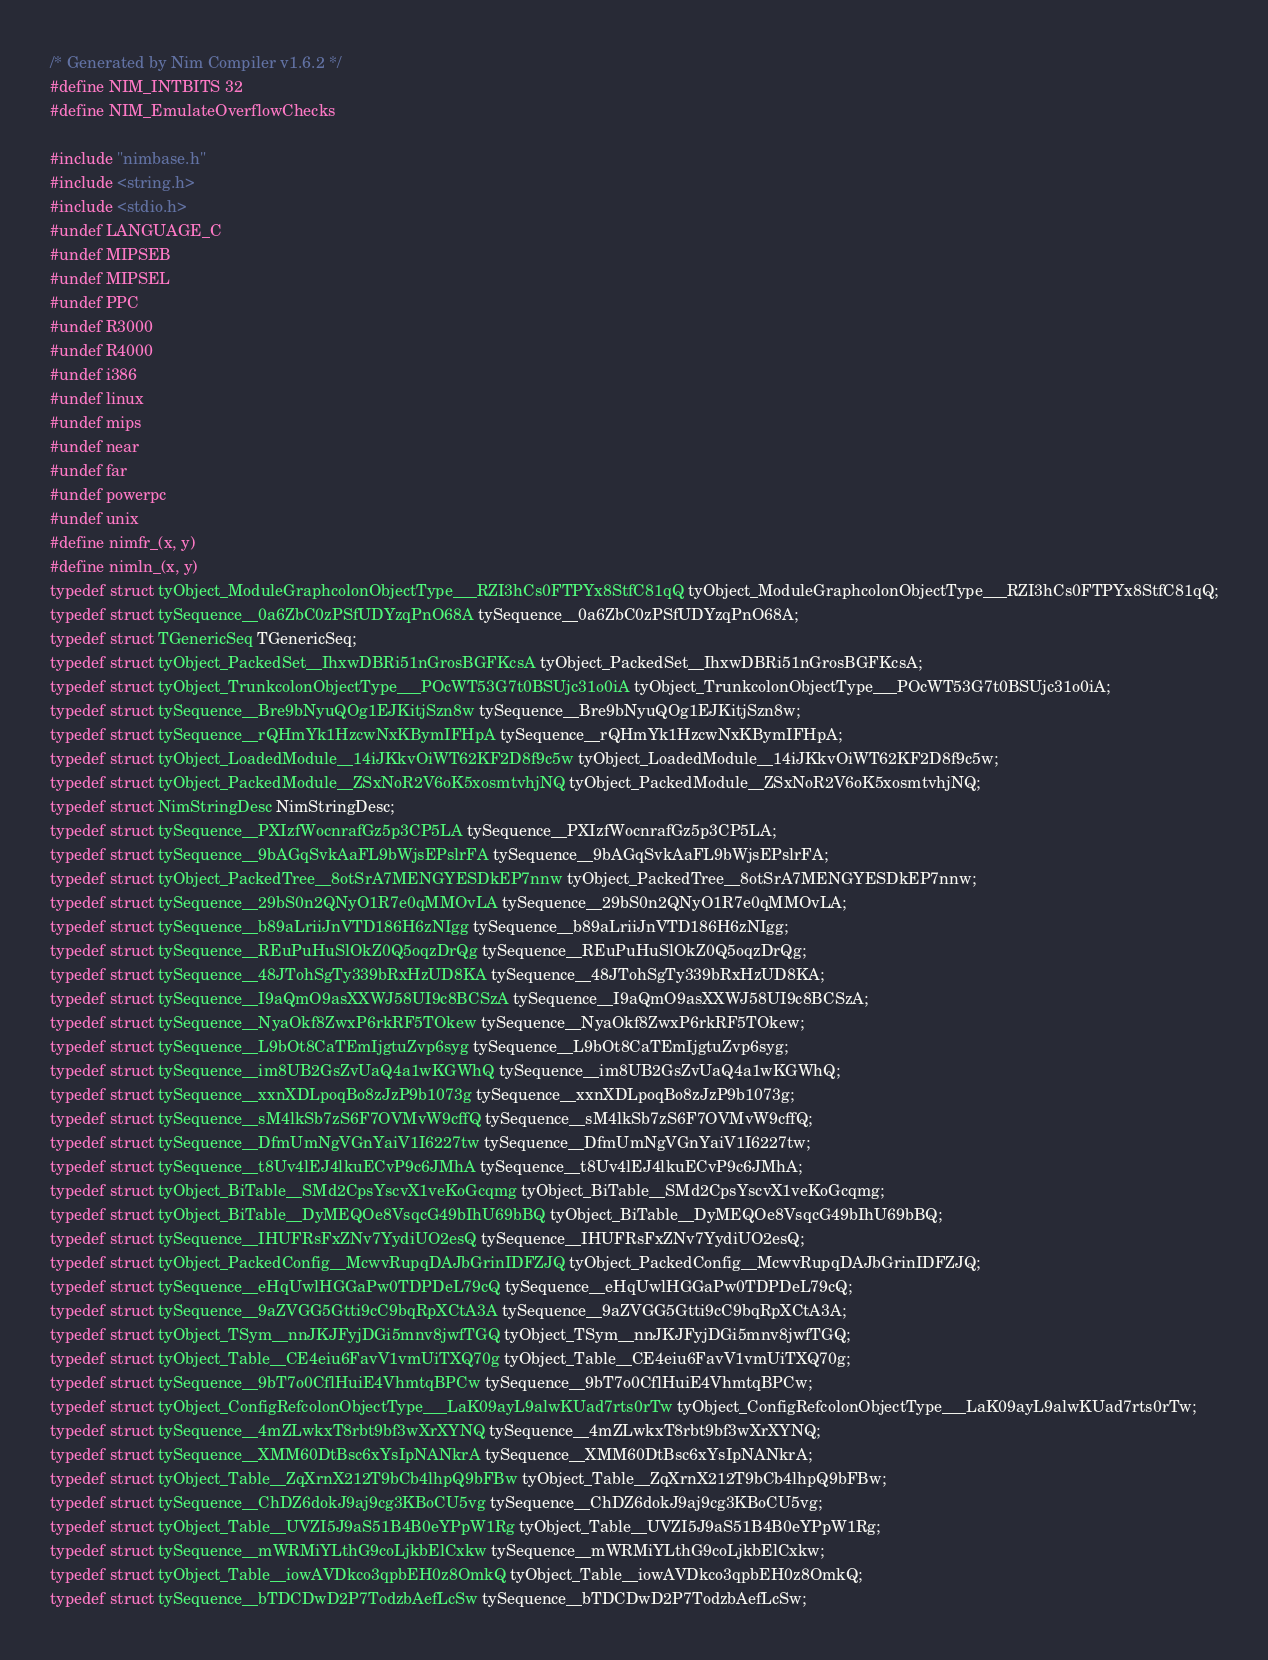Convert code to text. <code><loc_0><loc_0><loc_500><loc_500><_C_>/* Generated by Nim Compiler v1.6.2 */
#define NIM_INTBITS 32
#define NIM_EmulateOverflowChecks

#include "nimbase.h"
#include <string.h>
#include <stdio.h>
#undef LANGUAGE_C
#undef MIPSEB
#undef MIPSEL
#undef PPC
#undef R3000
#undef R4000
#undef i386
#undef linux
#undef mips
#undef near
#undef far
#undef powerpc
#undef unix
#define nimfr_(x, y)
#define nimln_(x, y)
typedef struct tyObject_ModuleGraphcolonObjectType___RZI3hCs0FTPYx8StfC81qQ tyObject_ModuleGraphcolonObjectType___RZI3hCs0FTPYx8StfC81qQ;
typedef struct tySequence__0a6ZbC0zPSfUDYzqPnO68A tySequence__0a6ZbC0zPSfUDYzqPnO68A;
typedef struct TGenericSeq TGenericSeq;
typedef struct tyObject_PackedSet__IhxwDBRi51nGrosBGFKcsA tyObject_PackedSet__IhxwDBRi51nGrosBGFKcsA;
typedef struct tyObject_TrunkcolonObjectType___POcWT53G7t0BSUjc31o0iA tyObject_TrunkcolonObjectType___POcWT53G7t0BSUjc31o0iA;
typedef struct tySequence__Bre9bNyuQOg1EJKitjSzn8w tySequence__Bre9bNyuQOg1EJKitjSzn8w;
typedef struct tySequence__rQHmYk1HzcwNxKBymIFHpA tySequence__rQHmYk1HzcwNxKBymIFHpA;
typedef struct tyObject_LoadedModule__14iJKkvOiWT62KF2D8f9c5w tyObject_LoadedModule__14iJKkvOiWT62KF2D8f9c5w;
typedef struct tyObject_PackedModule__ZSxNoR2V6oK5xosmtvhjNQ tyObject_PackedModule__ZSxNoR2V6oK5xosmtvhjNQ;
typedef struct NimStringDesc NimStringDesc;
typedef struct tySequence__PXIzfWocnrafGz5p3CP5LA tySequence__PXIzfWocnrafGz5p3CP5LA;
typedef struct tySequence__9bAGqSvkAaFL9bWjsEPslrFA tySequence__9bAGqSvkAaFL9bWjsEPslrFA;
typedef struct tyObject_PackedTree__8otSrA7MENGYESDkEP7nnw tyObject_PackedTree__8otSrA7MENGYESDkEP7nnw;
typedef struct tySequence__29bS0n2QNyO1R7e0qMMOvLA tySequence__29bS0n2QNyO1R7e0qMMOvLA;
typedef struct tySequence__b89aLriiJnVTD186H6zNIgg tySequence__b89aLriiJnVTD186H6zNIgg;
typedef struct tySequence__REuPuHuSlOkZ0Q5oqzDrQg tySequence__REuPuHuSlOkZ0Q5oqzDrQg;
typedef struct tySequence__48JTohSgTy339bRxHzUD8KA tySequence__48JTohSgTy339bRxHzUD8KA;
typedef struct tySequence__I9aQmO9asXXWJ58UI9c8BCSzA tySequence__I9aQmO9asXXWJ58UI9c8BCSzA;
typedef struct tySequence__NyaOkf8ZwxP6rkRF5TOkew tySequence__NyaOkf8ZwxP6rkRF5TOkew;
typedef struct tySequence__L9bOt8CaTEmIjgtuZvp6syg tySequence__L9bOt8CaTEmIjgtuZvp6syg;
typedef struct tySequence__im8UB2GsZvUaQ4a1wKGWhQ tySequence__im8UB2GsZvUaQ4a1wKGWhQ;
typedef struct tySequence__xxnXDLpoqBo8zJzP9b1073g tySequence__xxnXDLpoqBo8zJzP9b1073g;
typedef struct tySequence__sM4lkSb7zS6F7OVMvW9cffQ tySequence__sM4lkSb7zS6F7OVMvW9cffQ;
typedef struct tySequence__DfmUmNgVGnYaiV1I6227tw tySequence__DfmUmNgVGnYaiV1I6227tw;
typedef struct tySequence__t8Uv4lEJ4lkuECvP9c6JMhA tySequence__t8Uv4lEJ4lkuECvP9c6JMhA;
typedef struct tyObject_BiTable__SMd2CpsYscvX1veKoGcqmg tyObject_BiTable__SMd2CpsYscvX1veKoGcqmg;
typedef struct tyObject_BiTable__DyMEQOe8VsqcG49bIhU69bBQ tyObject_BiTable__DyMEQOe8VsqcG49bIhU69bBQ;
typedef struct tySequence__IHUFRsFxZNv7YydiUO2esQ tySequence__IHUFRsFxZNv7YydiUO2esQ;
typedef struct tyObject_PackedConfig__McwvRupqDAJbGrinIDFZJQ tyObject_PackedConfig__McwvRupqDAJbGrinIDFZJQ;
typedef struct tySequence__eHqUwlHGGaPw0TDPDeL79cQ tySequence__eHqUwlHGGaPw0TDPDeL79cQ;
typedef struct tySequence__9aZVGG5Gtti9cC9bqRpXCtA3A tySequence__9aZVGG5Gtti9cC9bqRpXCtA3A;
typedef struct tyObject_TSym__nnJKJFyjDGi5mnv8jwfTGQ tyObject_TSym__nnJKJFyjDGi5mnv8jwfTGQ;
typedef struct tyObject_Table__CE4eiu6FavV1vmUiTXQ70g tyObject_Table__CE4eiu6FavV1vmUiTXQ70g;
typedef struct tySequence__9bT7o0CflHuiE4VhmtqBPCw tySequence__9bT7o0CflHuiE4VhmtqBPCw;
typedef struct tyObject_ConfigRefcolonObjectType___LaK09ayL9alwKUad7rts0rTw tyObject_ConfigRefcolonObjectType___LaK09ayL9alwKUad7rts0rTw;
typedef struct tySequence__4mZLwkxT8rbt9bf3wXrXYNQ tySequence__4mZLwkxT8rbt9bf3wXrXYNQ;
typedef struct tySequence__XMM60DtBsc6xYsIpNANkrA tySequence__XMM60DtBsc6xYsIpNANkrA;
typedef struct tyObject_Table__ZqXrnX212T9bCb4lhpQ9bFBw tyObject_Table__ZqXrnX212T9bCb4lhpQ9bFBw;
typedef struct tySequence__ChDZ6dokJ9aj9cg3KBoCU5vg tySequence__ChDZ6dokJ9aj9cg3KBoCU5vg;
typedef struct tyObject_Table__UVZI5J9aS51B4B0eYPpW1Rg tyObject_Table__UVZI5J9aS51B4B0eYPpW1Rg;
typedef struct tySequence__mWRMiYLthG9coLjkbElCxkw tySequence__mWRMiYLthG9coLjkbElCxkw;
typedef struct tyObject_Table__iowAVDkco3qpbEH0z8OmkQ tyObject_Table__iowAVDkco3qpbEH0z8OmkQ;
typedef struct tySequence__bTDCDwD2P7TodzbAefLcSw tySequence__bTDCDwD2P7TodzbAefLcSw;</code> 